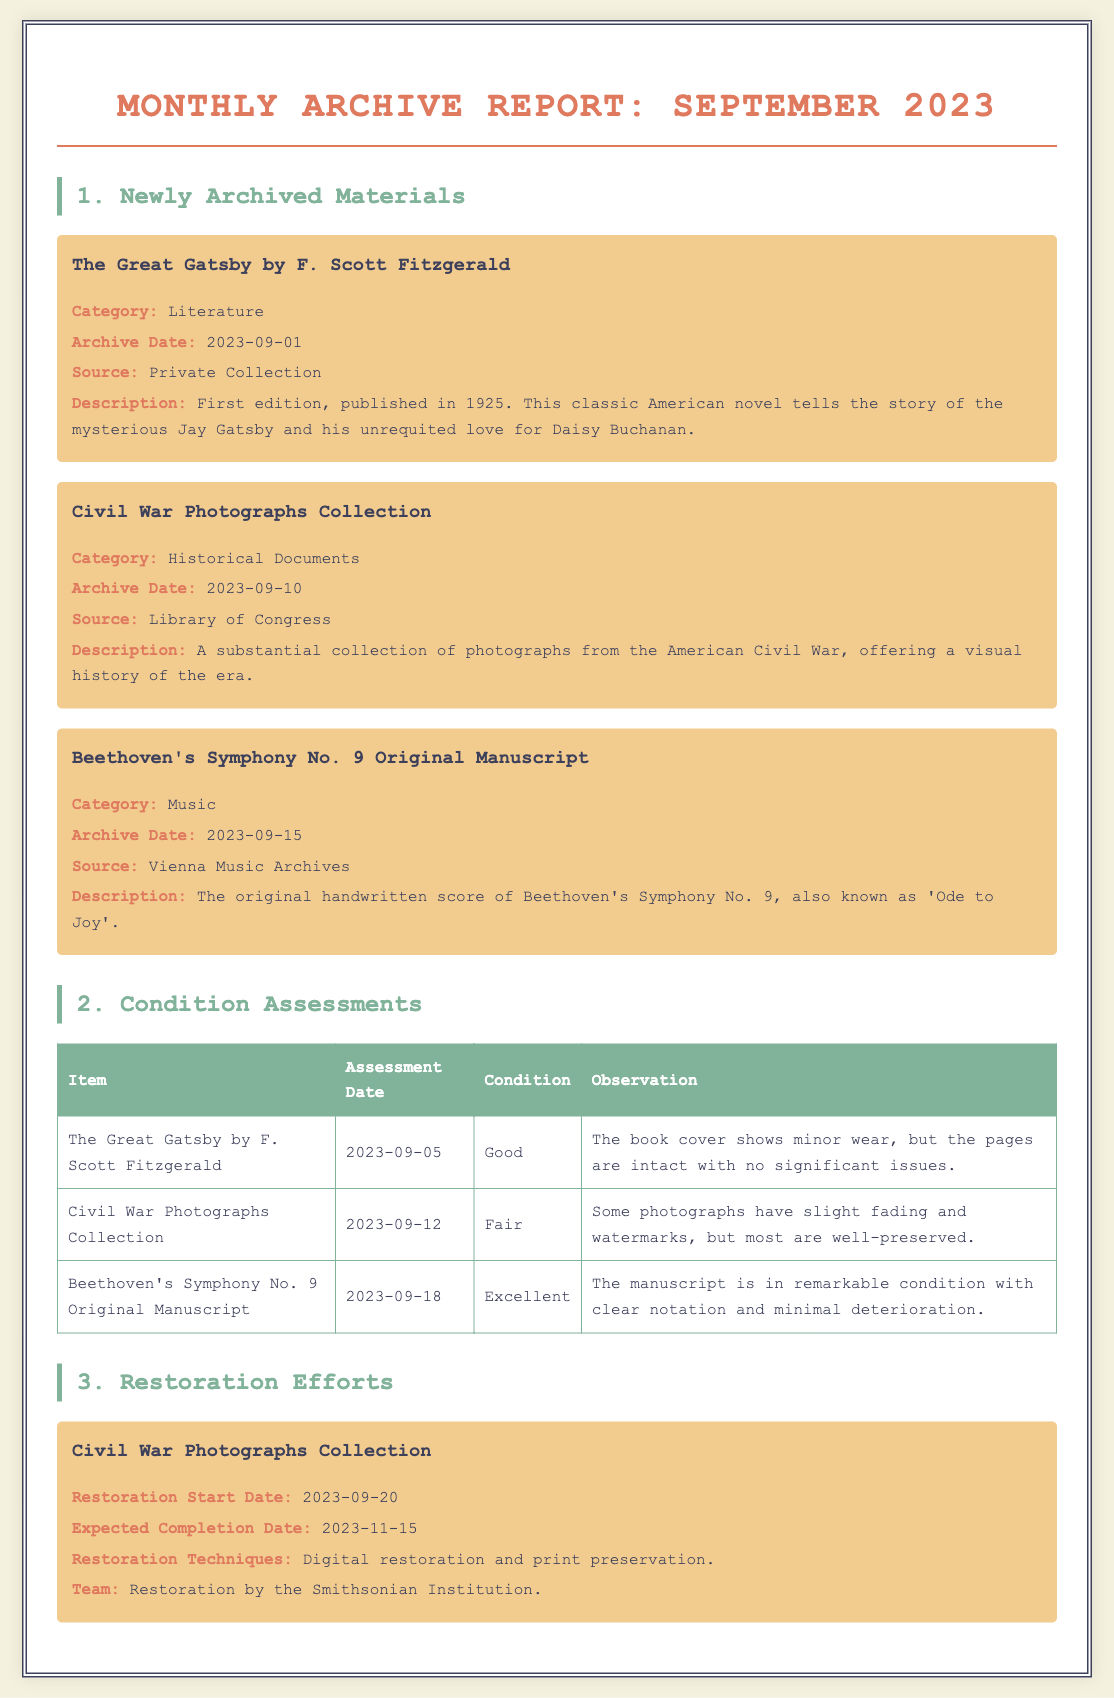What is the title of the first newly archived material? The title of the first newly archived material is listed in the report under "Newly Archived Materials".
Answer: The Great Gatsby by F. Scott Fitzgerald When was Beethoven's Symphony No. 9 archived? The document states the archive date for Beethoven's Symphony No. 9, which is in September.
Answer: 2023-09-15 What condition is the Civil War Photographs Collection assessed as? The condition is found under "Condition Assessments" for this specific collection.
Answer: Fair Who is responsible for the restoration of the Civil War Photographs Collection? The document specifies the team responsible for the restoration efforts outlined in the section on Restoration Efforts.
Answer: Smithsonian Institution What restoration technique is used for the Civil War Photographs Collection? The techniques used for restoration are clearly stated in the restoration section of the document.
Answer: Digital restoration and print preservation How many newly archived materials are listed in the document? The total number of newly archived materials can be counted from the section titled "Newly Archived Materials".
Answer: Three 